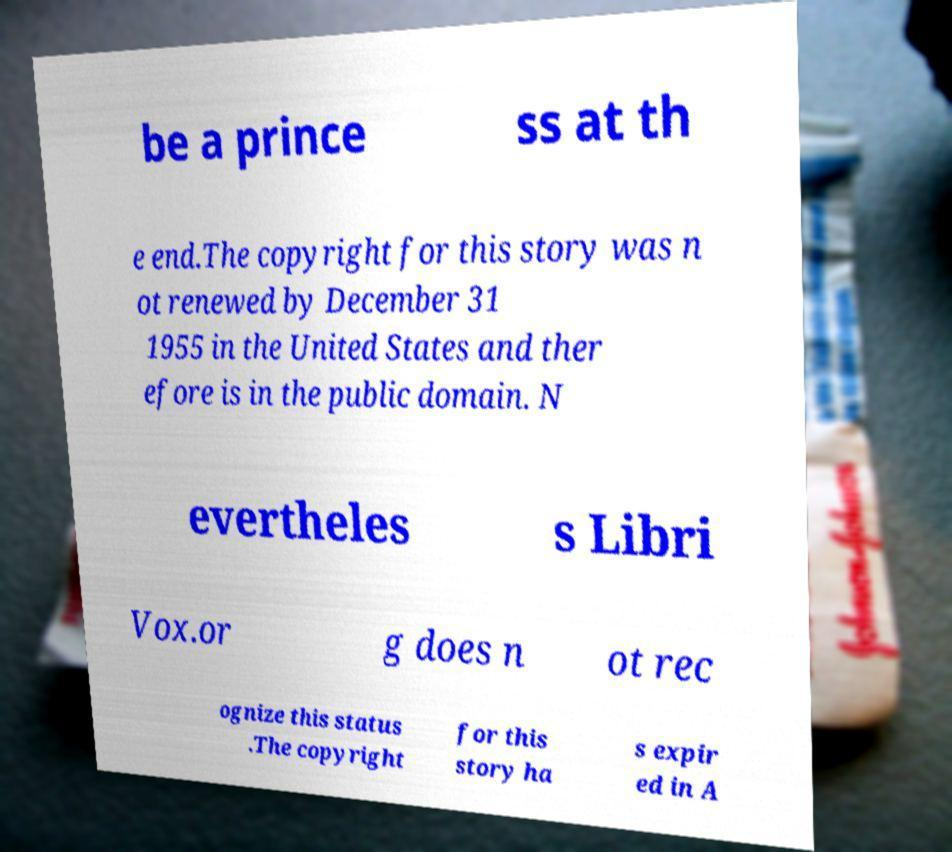Can you read and provide the text displayed in the image?This photo seems to have some interesting text. Can you extract and type it out for me? be a prince ss at th e end.The copyright for this story was n ot renewed by December 31 1955 in the United States and ther efore is in the public domain. N evertheles s Libri Vox.or g does n ot rec ognize this status .The copyright for this story ha s expir ed in A 